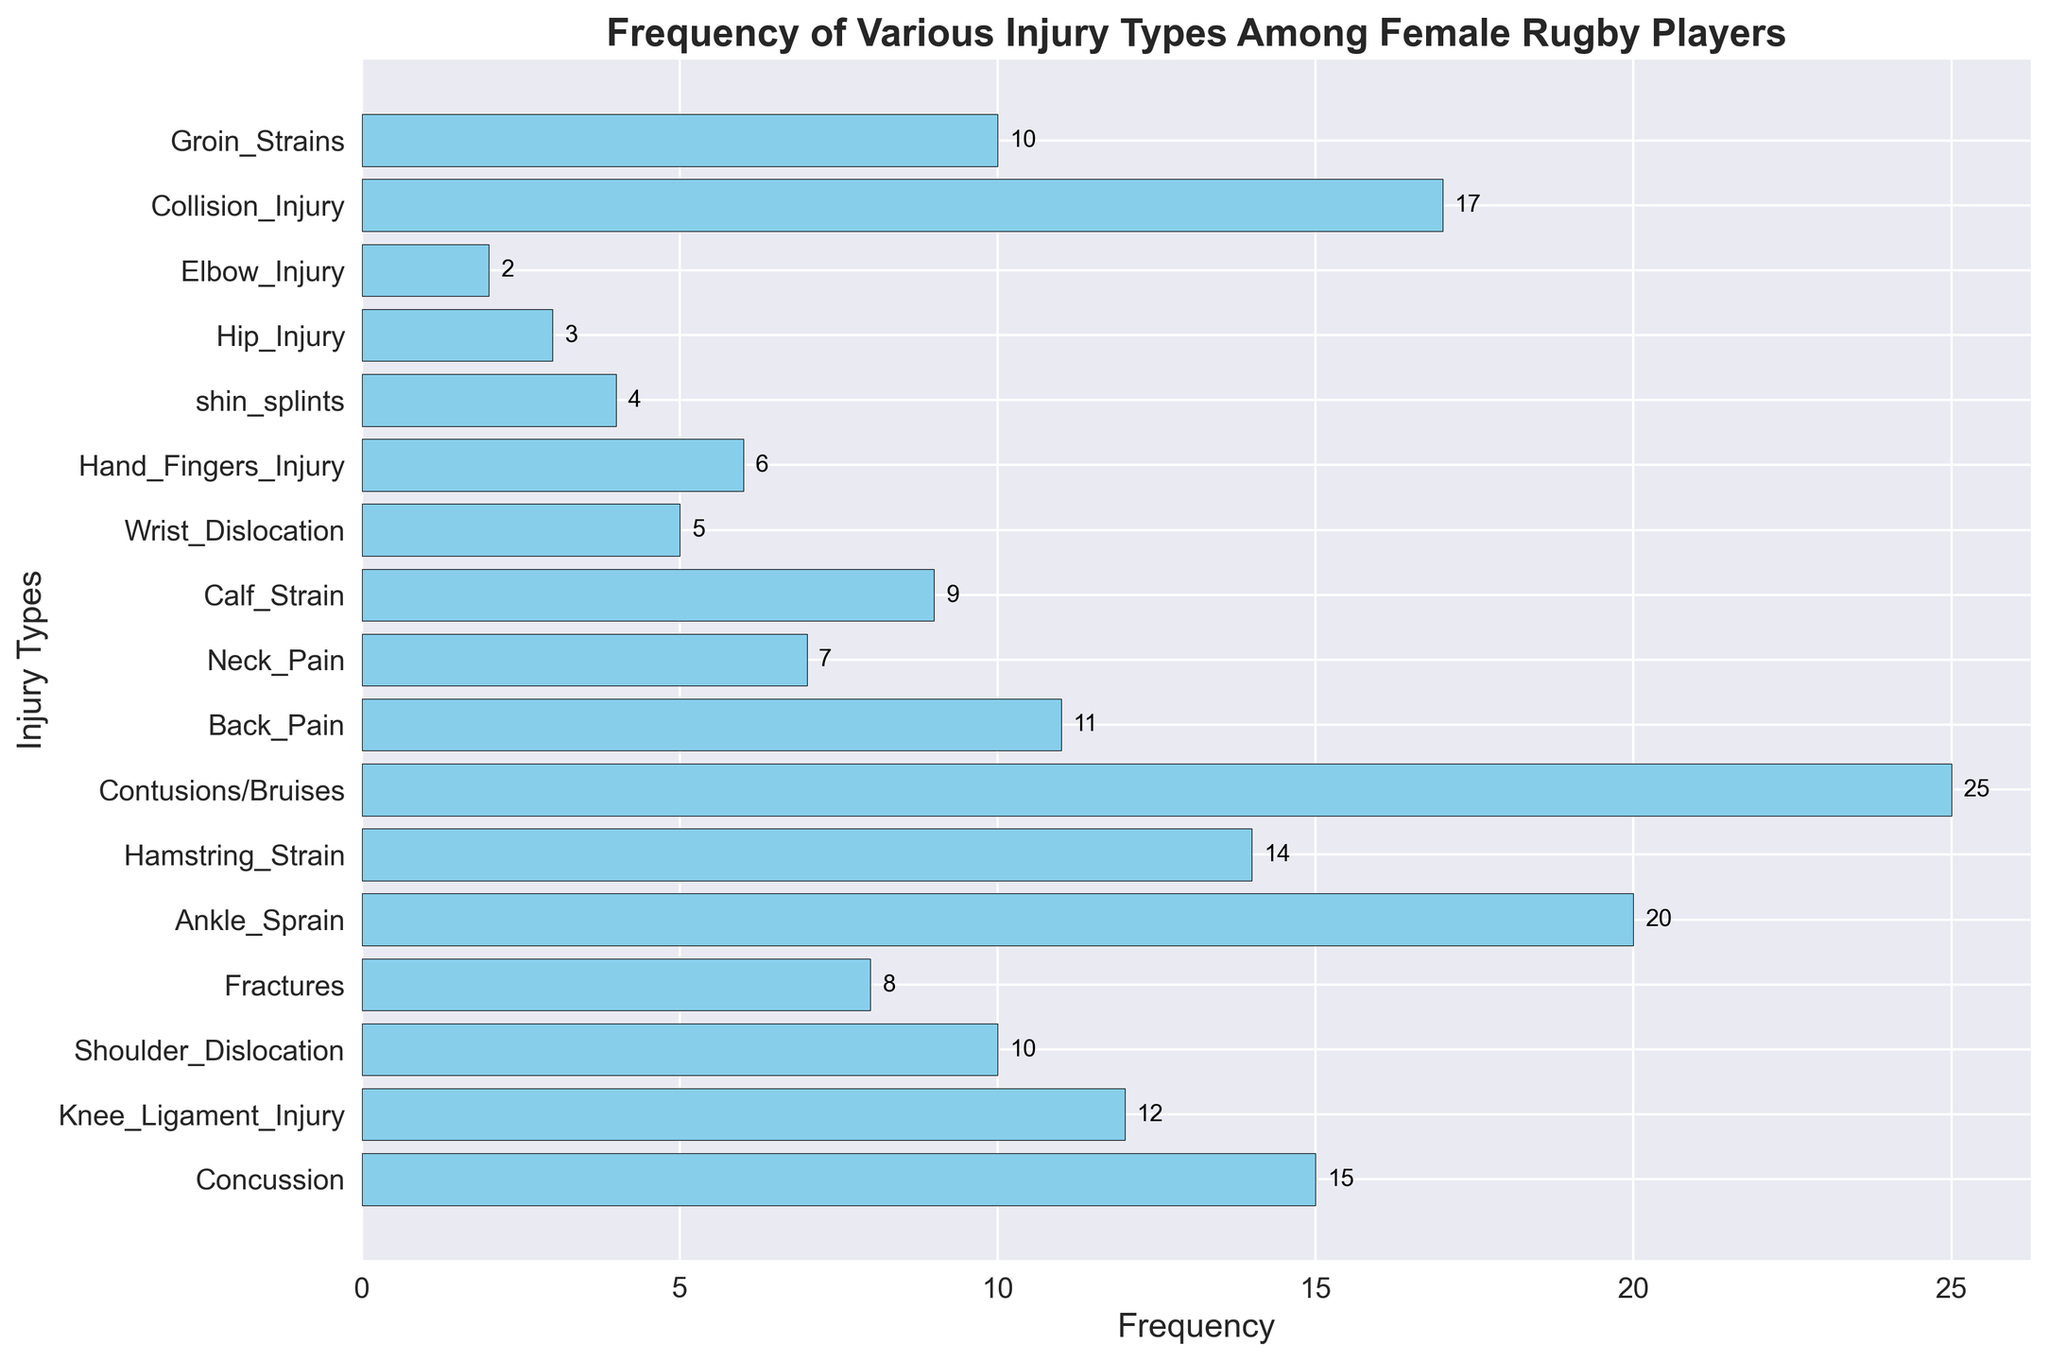Which injury type had the highest frequency? To identify the injury type with the highest frequency, look for the longest horizontal bar in the histogram. The longest bar represents the injury type "Contusions/Bruises."
Answer: Contusions/Bruises What is the combined frequency of Knee Ligament Injuries and Shoulder Dislocations? To find the combined frequency, sum the frequencies of Knee Ligament Injuries (12) and Shoulder Dislocations (10): 12 + 10 = 22.
Answer: 22 Which injury type had the lowest frequency, and what is its frequency? To determine the injury type with the lowest frequency, look for the shortest horizontal bar. The shortest bar corresponds to "Elbow Injury," which has a frequency of 2.
Answer: Elbow Injury, 2 How does the frequency of Ankle Sprains compare to Concussions? By comparing the lengths of the bars for Ankle Sprains (20) and Concussions (15), Ankle Sprains have a higher frequency.
Answer: Ankle Sprains have a higher frequency than Concussions What is the total frequency of injuries related to the upper body (Shoulder Dislocation, Wrist Dislocation, Hand/Fingers Injury, Elbow Injury)? Add the frequencies of the specified injuries: Shoulder Dislocation (10) + Wrist Dislocation (5) + Hand/Fingers Injury (6) + Elbow Injury (2): 10 + 5 + 6 + 2 = 23.
Answer: 23 What is the frequency difference between Calf Strains and Neck Pain? To find the difference, subtract the frequency of Neck Pain (7) from the frequency of Calf Strains (9): 9 - 7 = 2.
Answer: 2 What is the average frequency of the top three most common injury types? First, identify the top three injury types by frequency: Contusions/Bruises (25), Ankle Sprain (20), and Collision Injury (17). Add these frequencies and divide by 3: (25 + 20 + 17) / 3 = 62 / 3 ≈ 20.67.
Answer: 20.67 How many types of injuries have a frequency higher than 10? Count the bars with a frequency greater than 10: Concussion, Knee Ligament Injury, Ankle Sprain, Hamstring Strain, Contusions/Bruises, Back Pain, Collision Injury. This equals 7 injury types.
Answer: 7 What is the frequency sum of injuries related to the leg (Knee Ligament Injury, Ankle Sprain, Hamstring Strain, Calf Strain, and shin splints)? Add the frequencies: Knee Ligament Injury (12) + Ankle Sprain (20) + Hamstring Strain (14) + Calf Strain (9) + shin splints (4): 12 + 20 + 14 + 9 + 4 = 59.
Answer: 59 